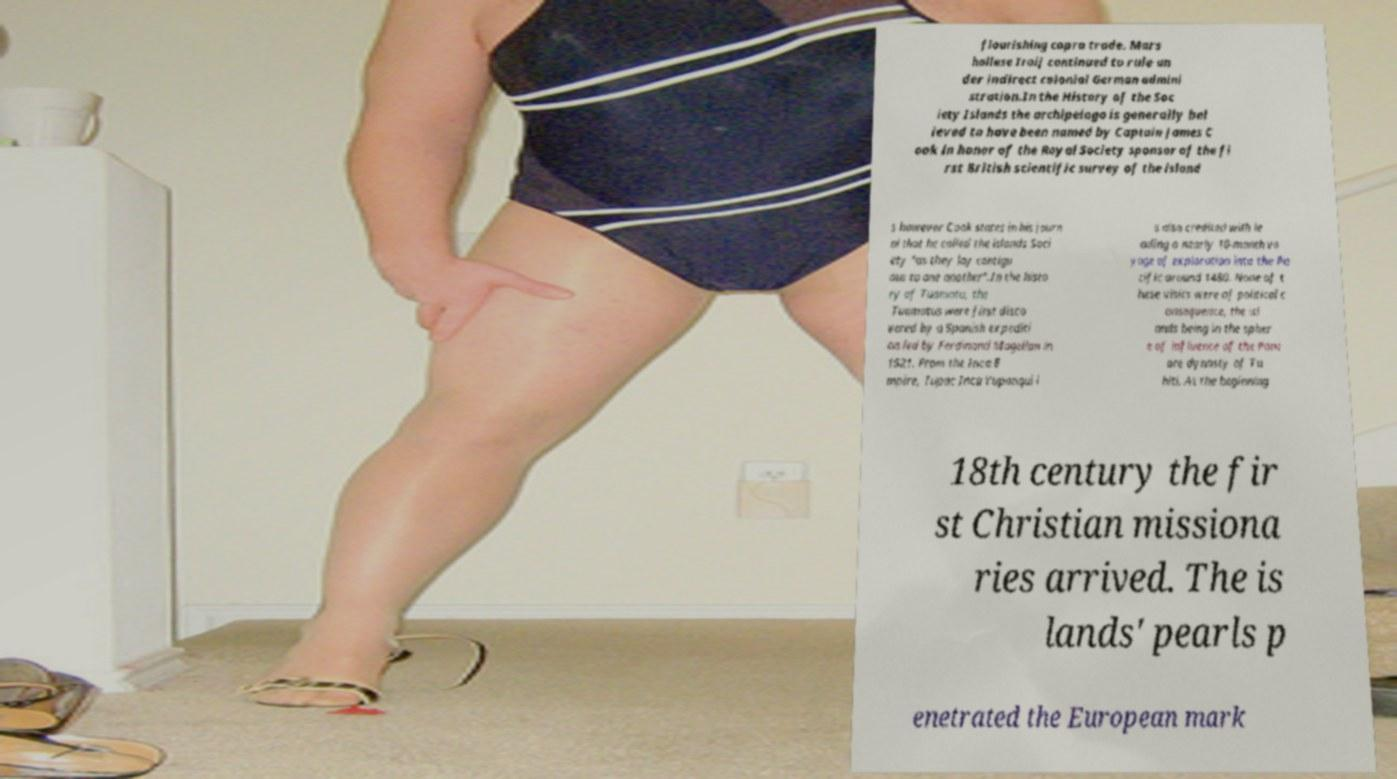Could you extract and type out the text from this image? flourishing copra trade. Mars hallese Iroij continued to rule un der indirect colonial German admini stration.In the History of the Soc iety Islands the archipelago is generally bel ieved to have been named by Captain James C ook in honor of the Royal Society sponsor of the fi rst British scientific survey of the island s however Cook states in his journ al that he called the islands Soci ety "as they lay contigu ous to one another".In the histo ry of Tuamotu, the Tuamotus were first disco vered by a Spanish expediti on led by Ferdinand Magellan in 1521. From the Inca E mpire, Tupac Inca Yupanqui i s also credited with le ading a nearly 10-month vo yage of exploration into the Pa cific around 1480. None of t hese visits were of political c onsequence, the isl ands being in the spher e of influence of the Pom are dynasty of Ta hiti. At the beginning 18th century the fir st Christian missiona ries arrived. The is lands' pearls p enetrated the European mark 